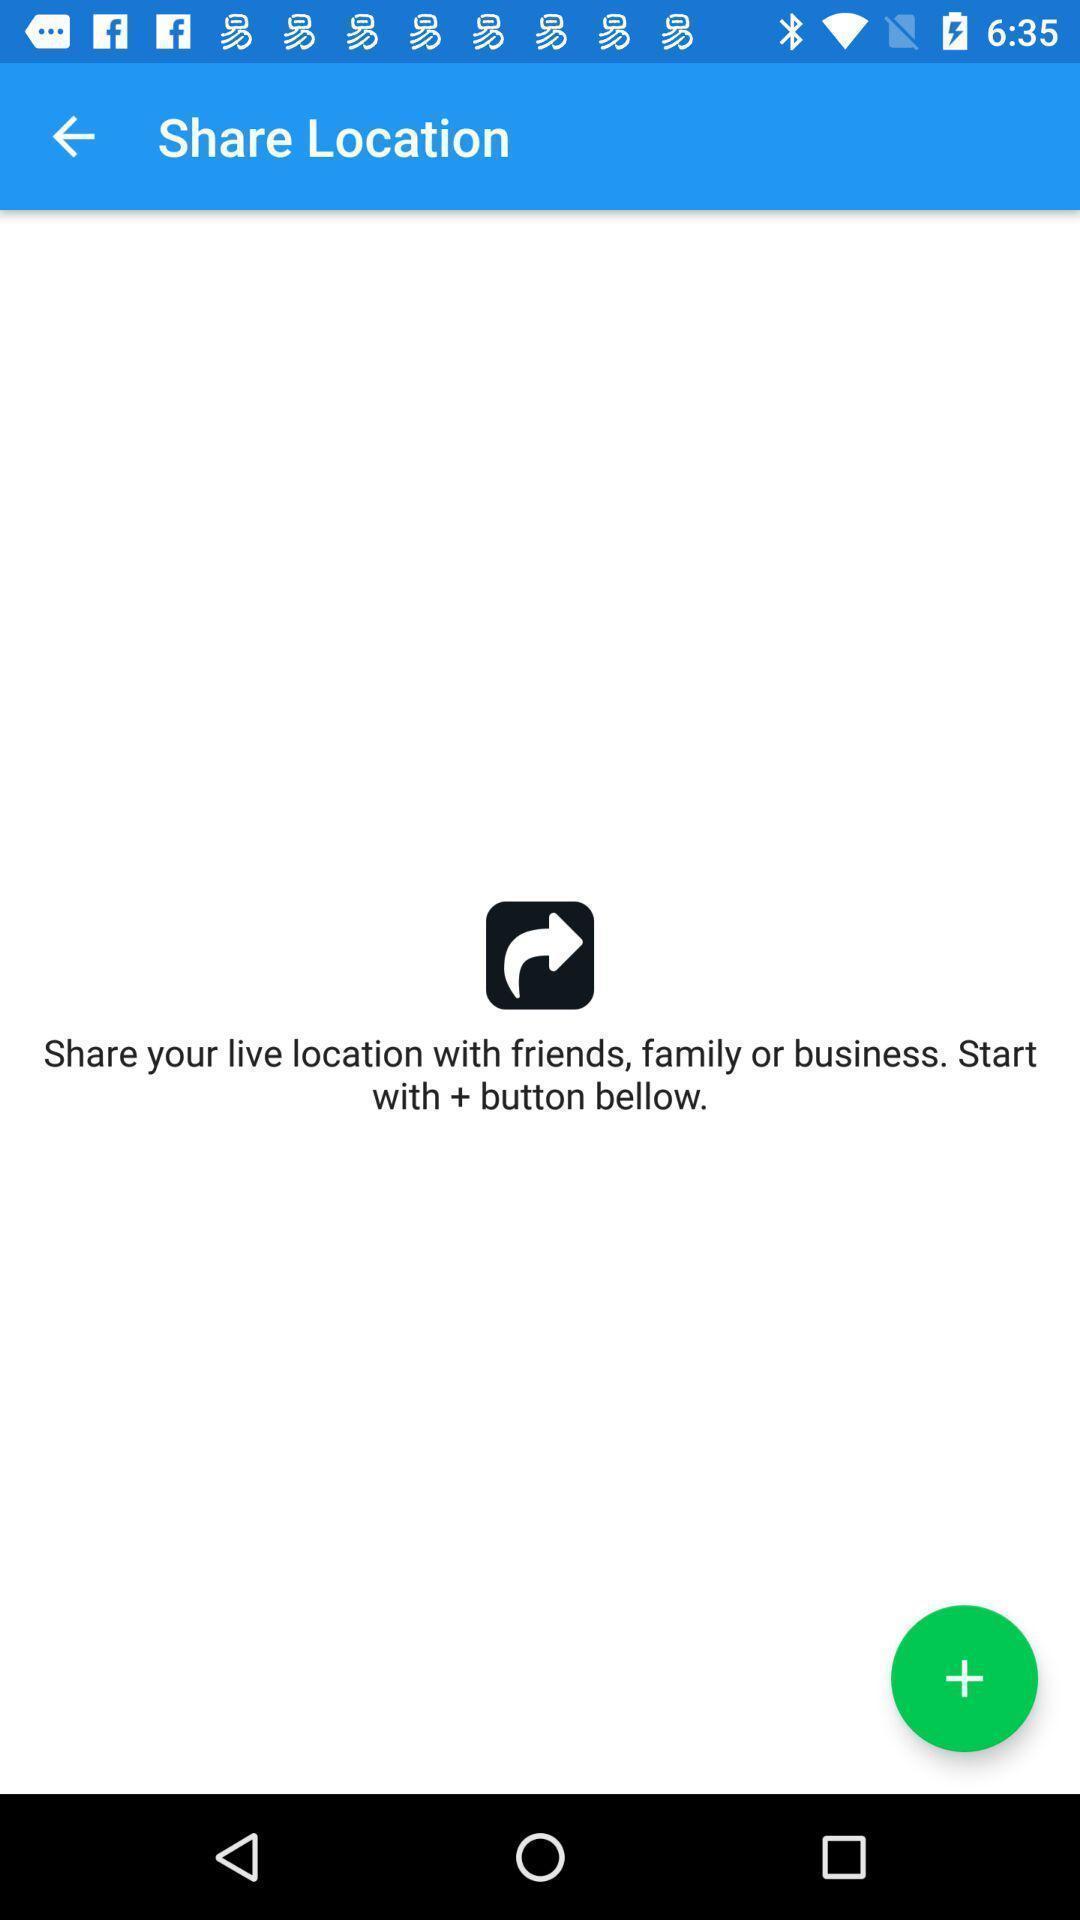Provide a detailed account of this screenshot. Page displaying to share live location with a start button. 